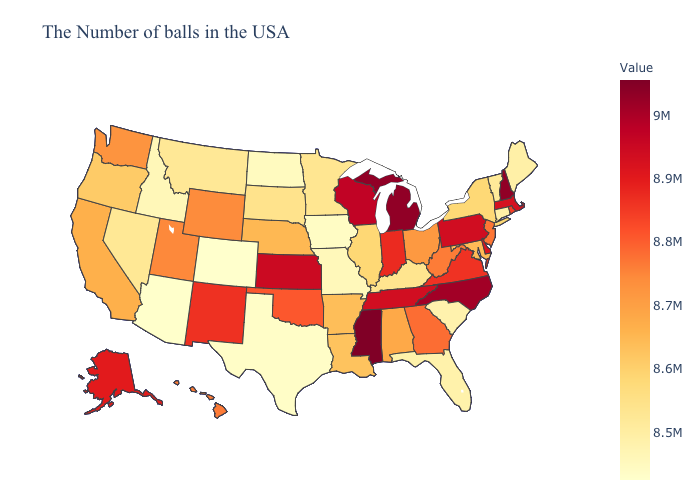Among the states that border Minnesota , does Wisconsin have the lowest value?
Short answer required. No. Which states have the lowest value in the USA?
Write a very short answer. Colorado. Does Nevada have a higher value than Arizona?
Keep it brief. Yes. Among the states that border New Hampshire , which have the highest value?
Quick response, please. Massachusetts. 